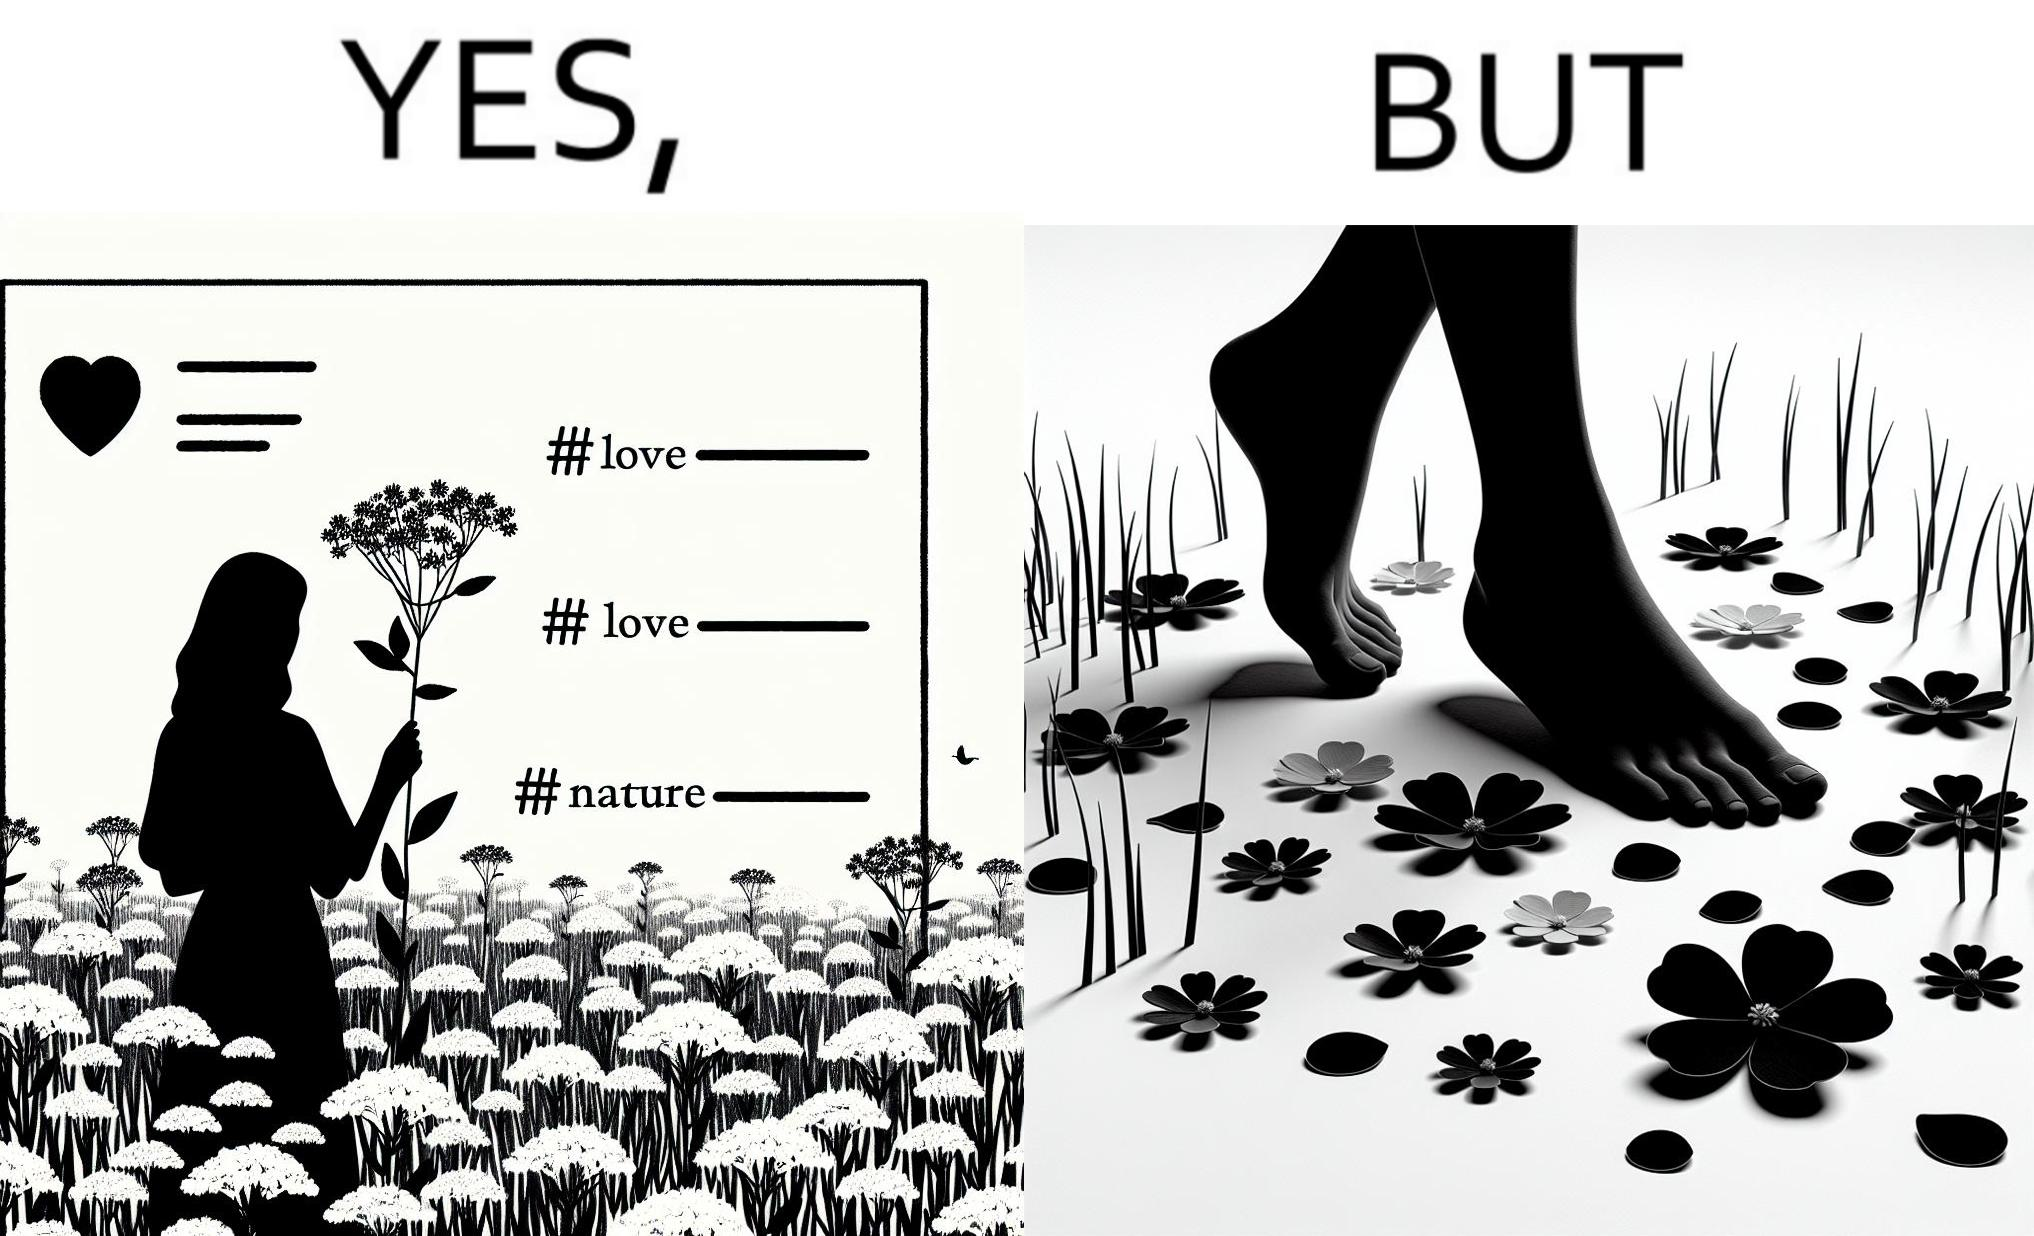Describe what you see in the left and right parts of this image. In the left part of the image: a social media post showing a woman in a field of flowers, with hashtags such as #naturelovers, #lovenature, #nature. In the right part of the image: feet stepping on flower petals surrounded by grass. 